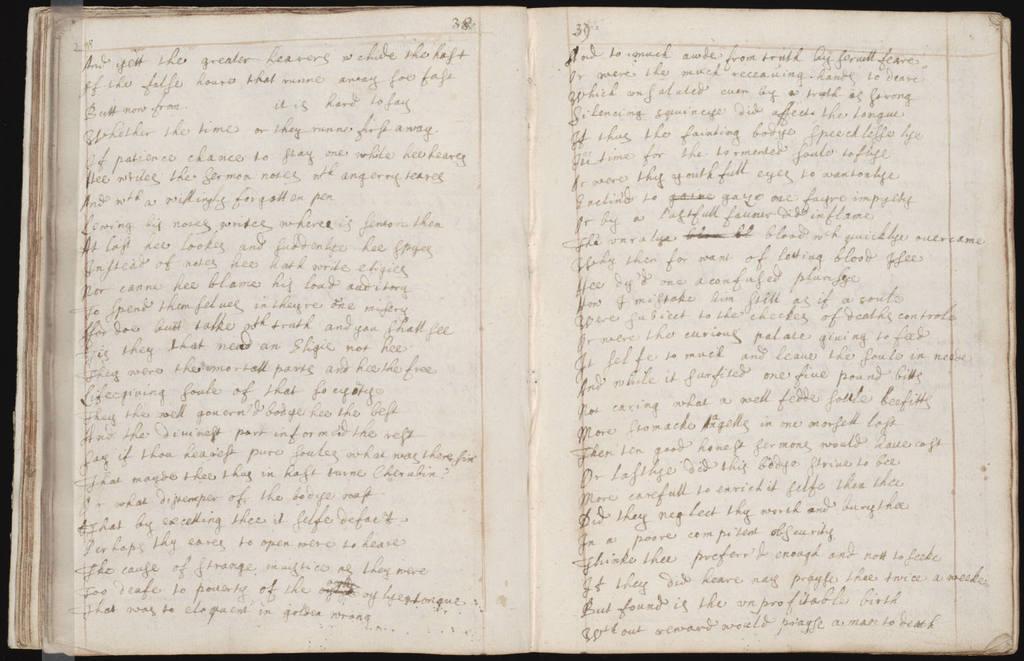How would you summarize this image in a sentence or two? In this image I can see pages of a book and on it I can see something is written. I can see colour of these pages are white. 